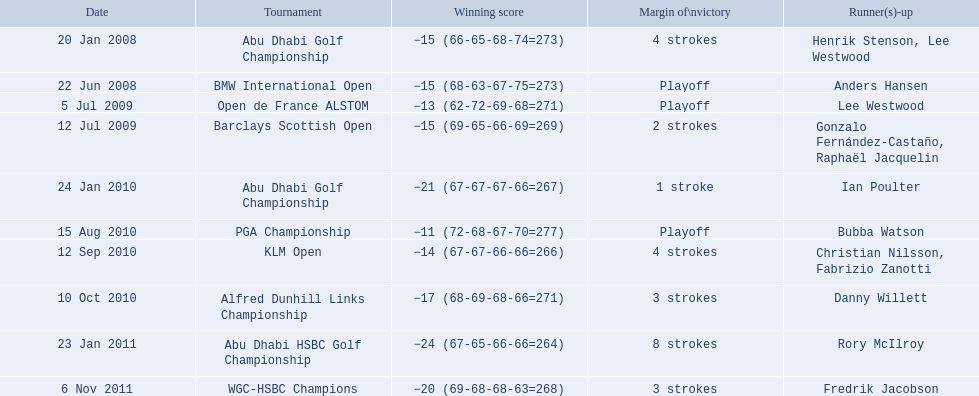How many strokes were in the klm open by martin kaymer? 4 strokes. How many strokes were in the abu dhabi golf championship? 4 strokes. How many more strokes were there in the klm than the barclays open? 2 strokes. 